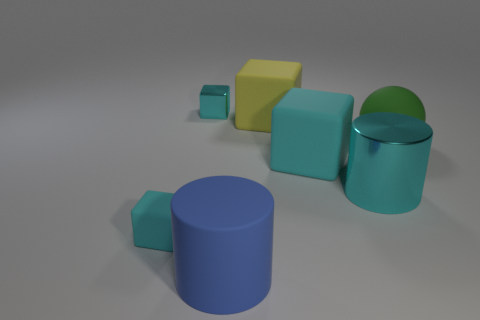What is the material of the cyan object that is the same shape as the big blue thing?
Offer a terse response. Metal. There is a small cyan object behind the big matte block that is behind the big green rubber object; how many matte objects are left of it?
Your response must be concise. 1. There is a thing to the right of the big metallic cylinder; does it have the same color as the rubber block behind the big matte sphere?
Offer a terse response. No. Is there anything else that is the same color as the tiny metallic thing?
Offer a very short reply. Yes. The tiny thing that is in front of the green thing that is on the right side of the cyan shiny cylinder is what color?
Your response must be concise. Cyan. Are any spheres visible?
Offer a terse response. Yes. What is the color of the cube that is behind the large metallic cylinder and in front of the yellow rubber thing?
Your answer should be compact. Cyan. Does the rubber thing behind the large green rubber thing have the same size as the cyan matte object that is right of the large yellow matte cube?
Provide a succinct answer. Yes. How many other objects are the same size as the yellow object?
Your answer should be very brief. 4. What number of blue cylinders are to the right of the matte object that is behind the green object?
Give a very brief answer. 0. 